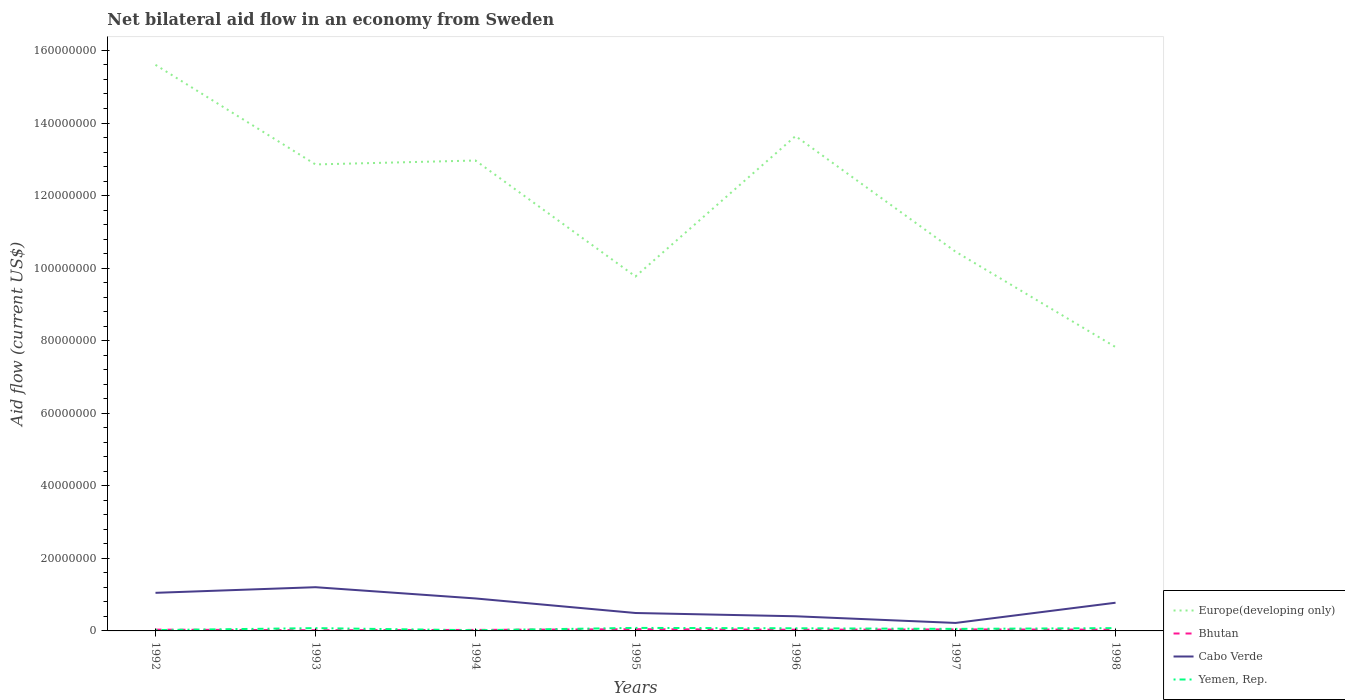Is the number of lines equal to the number of legend labels?
Your response must be concise. Yes. Across all years, what is the maximum net bilateral aid flow in Bhutan?
Your answer should be very brief. 1.90e+05. What is the difference between the highest and the second highest net bilateral aid flow in Cabo Verde?
Provide a short and direct response. 9.85e+06. What is the difference between the highest and the lowest net bilateral aid flow in Yemen, Rep.?
Provide a short and direct response. 4. How many years are there in the graph?
Make the answer very short. 7. Where does the legend appear in the graph?
Your answer should be very brief. Bottom right. How many legend labels are there?
Provide a succinct answer. 4. How are the legend labels stacked?
Offer a terse response. Vertical. What is the title of the graph?
Your response must be concise. Net bilateral aid flow in an economy from Sweden. Does "Uzbekistan" appear as one of the legend labels in the graph?
Make the answer very short. No. What is the label or title of the X-axis?
Your answer should be compact. Years. What is the label or title of the Y-axis?
Offer a very short reply. Aid flow (current US$). What is the Aid flow (current US$) of Europe(developing only) in 1992?
Keep it short and to the point. 1.56e+08. What is the Aid flow (current US$) of Cabo Verde in 1992?
Offer a very short reply. 1.05e+07. What is the Aid flow (current US$) of Europe(developing only) in 1993?
Your answer should be very brief. 1.29e+08. What is the Aid flow (current US$) in Bhutan in 1993?
Offer a terse response. 1.90e+05. What is the Aid flow (current US$) of Cabo Verde in 1993?
Offer a terse response. 1.20e+07. What is the Aid flow (current US$) of Yemen, Rep. in 1993?
Keep it short and to the point. 7.70e+05. What is the Aid flow (current US$) of Europe(developing only) in 1994?
Keep it short and to the point. 1.30e+08. What is the Aid flow (current US$) in Bhutan in 1994?
Ensure brevity in your answer.  2.80e+05. What is the Aid flow (current US$) in Cabo Verde in 1994?
Your response must be concise. 8.95e+06. What is the Aid flow (current US$) of Europe(developing only) in 1995?
Give a very brief answer. 9.77e+07. What is the Aid flow (current US$) in Cabo Verde in 1995?
Provide a short and direct response. 4.94e+06. What is the Aid flow (current US$) of Yemen, Rep. in 1995?
Make the answer very short. 8.30e+05. What is the Aid flow (current US$) of Europe(developing only) in 1996?
Ensure brevity in your answer.  1.36e+08. What is the Aid flow (current US$) in Cabo Verde in 1996?
Ensure brevity in your answer.  4.04e+06. What is the Aid flow (current US$) of Yemen, Rep. in 1996?
Give a very brief answer. 7.30e+05. What is the Aid flow (current US$) of Europe(developing only) in 1997?
Your answer should be compact. 1.05e+08. What is the Aid flow (current US$) in Cabo Verde in 1997?
Give a very brief answer. 2.20e+06. What is the Aid flow (current US$) in Yemen, Rep. in 1997?
Offer a terse response. 5.60e+05. What is the Aid flow (current US$) of Europe(developing only) in 1998?
Your response must be concise. 7.82e+07. What is the Aid flow (current US$) of Bhutan in 1998?
Your response must be concise. 3.50e+05. What is the Aid flow (current US$) of Cabo Verde in 1998?
Your response must be concise. 7.77e+06. What is the Aid flow (current US$) in Yemen, Rep. in 1998?
Offer a very short reply. 7.70e+05. Across all years, what is the maximum Aid flow (current US$) of Europe(developing only)?
Your response must be concise. 1.56e+08. Across all years, what is the maximum Aid flow (current US$) in Cabo Verde?
Your response must be concise. 1.20e+07. Across all years, what is the maximum Aid flow (current US$) of Yemen, Rep.?
Ensure brevity in your answer.  8.30e+05. Across all years, what is the minimum Aid flow (current US$) in Europe(developing only)?
Offer a terse response. 7.82e+07. Across all years, what is the minimum Aid flow (current US$) in Cabo Verde?
Make the answer very short. 2.20e+06. Across all years, what is the minimum Aid flow (current US$) in Yemen, Rep.?
Give a very brief answer. 1.90e+05. What is the total Aid flow (current US$) of Europe(developing only) in the graph?
Offer a very short reply. 8.31e+08. What is the total Aid flow (current US$) of Bhutan in the graph?
Your response must be concise. 2.40e+06. What is the total Aid flow (current US$) of Cabo Verde in the graph?
Give a very brief answer. 5.04e+07. What is the total Aid flow (current US$) of Yemen, Rep. in the graph?
Ensure brevity in your answer.  4.08e+06. What is the difference between the Aid flow (current US$) of Europe(developing only) in 1992 and that in 1993?
Your answer should be very brief. 2.74e+07. What is the difference between the Aid flow (current US$) in Bhutan in 1992 and that in 1993?
Offer a very short reply. 1.60e+05. What is the difference between the Aid flow (current US$) of Cabo Verde in 1992 and that in 1993?
Provide a succinct answer. -1.55e+06. What is the difference between the Aid flow (current US$) of Yemen, Rep. in 1992 and that in 1993?
Make the answer very short. -5.40e+05. What is the difference between the Aid flow (current US$) in Europe(developing only) in 1992 and that in 1994?
Your response must be concise. 2.64e+07. What is the difference between the Aid flow (current US$) in Cabo Verde in 1992 and that in 1994?
Your answer should be very brief. 1.55e+06. What is the difference between the Aid flow (current US$) of Europe(developing only) in 1992 and that in 1995?
Make the answer very short. 5.83e+07. What is the difference between the Aid flow (current US$) of Bhutan in 1992 and that in 1995?
Ensure brevity in your answer.  -1.30e+05. What is the difference between the Aid flow (current US$) of Cabo Verde in 1992 and that in 1995?
Keep it short and to the point. 5.56e+06. What is the difference between the Aid flow (current US$) of Yemen, Rep. in 1992 and that in 1995?
Offer a terse response. -6.00e+05. What is the difference between the Aid flow (current US$) in Europe(developing only) in 1992 and that in 1996?
Give a very brief answer. 1.96e+07. What is the difference between the Aid flow (current US$) of Cabo Verde in 1992 and that in 1996?
Your answer should be compact. 6.46e+06. What is the difference between the Aid flow (current US$) of Yemen, Rep. in 1992 and that in 1996?
Provide a succinct answer. -5.00e+05. What is the difference between the Aid flow (current US$) of Europe(developing only) in 1992 and that in 1997?
Offer a very short reply. 5.15e+07. What is the difference between the Aid flow (current US$) of Bhutan in 1992 and that in 1997?
Provide a succinct answer. -7.00e+04. What is the difference between the Aid flow (current US$) in Cabo Verde in 1992 and that in 1997?
Keep it short and to the point. 8.30e+06. What is the difference between the Aid flow (current US$) of Yemen, Rep. in 1992 and that in 1997?
Offer a terse response. -3.30e+05. What is the difference between the Aid flow (current US$) in Europe(developing only) in 1992 and that in 1998?
Offer a terse response. 7.78e+07. What is the difference between the Aid flow (current US$) in Cabo Verde in 1992 and that in 1998?
Provide a succinct answer. 2.73e+06. What is the difference between the Aid flow (current US$) of Yemen, Rep. in 1992 and that in 1998?
Offer a terse response. -5.40e+05. What is the difference between the Aid flow (current US$) in Europe(developing only) in 1993 and that in 1994?
Your answer should be very brief. -1.08e+06. What is the difference between the Aid flow (current US$) in Cabo Verde in 1993 and that in 1994?
Ensure brevity in your answer.  3.10e+06. What is the difference between the Aid flow (current US$) in Yemen, Rep. in 1993 and that in 1994?
Offer a terse response. 5.80e+05. What is the difference between the Aid flow (current US$) of Europe(developing only) in 1993 and that in 1995?
Provide a succinct answer. 3.09e+07. What is the difference between the Aid flow (current US$) of Cabo Verde in 1993 and that in 1995?
Offer a terse response. 7.11e+06. What is the difference between the Aid flow (current US$) of Europe(developing only) in 1993 and that in 1996?
Your answer should be compact. -7.82e+06. What is the difference between the Aid flow (current US$) of Cabo Verde in 1993 and that in 1996?
Your answer should be very brief. 8.01e+06. What is the difference between the Aid flow (current US$) in Yemen, Rep. in 1993 and that in 1996?
Keep it short and to the point. 4.00e+04. What is the difference between the Aid flow (current US$) of Europe(developing only) in 1993 and that in 1997?
Provide a short and direct response. 2.40e+07. What is the difference between the Aid flow (current US$) in Bhutan in 1993 and that in 1997?
Your response must be concise. -2.30e+05. What is the difference between the Aid flow (current US$) in Cabo Verde in 1993 and that in 1997?
Your answer should be compact. 9.85e+06. What is the difference between the Aid flow (current US$) in Europe(developing only) in 1993 and that in 1998?
Your answer should be very brief. 5.03e+07. What is the difference between the Aid flow (current US$) in Bhutan in 1993 and that in 1998?
Provide a succinct answer. -1.60e+05. What is the difference between the Aid flow (current US$) of Cabo Verde in 1993 and that in 1998?
Keep it short and to the point. 4.28e+06. What is the difference between the Aid flow (current US$) of Yemen, Rep. in 1993 and that in 1998?
Make the answer very short. 0. What is the difference between the Aid flow (current US$) of Europe(developing only) in 1994 and that in 1995?
Make the answer very short. 3.20e+07. What is the difference between the Aid flow (current US$) of Cabo Verde in 1994 and that in 1995?
Your response must be concise. 4.01e+06. What is the difference between the Aid flow (current US$) in Yemen, Rep. in 1994 and that in 1995?
Offer a very short reply. -6.40e+05. What is the difference between the Aid flow (current US$) in Europe(developing only) in 1994 and that in 1996?
Provide a short and direct response. -6.74e+06. What is the difference between the Aid flow (current US$) of Cabo Verde in 1994 and that in 1996?
Your answer should be compact. 4.91e+06. What is the difference between the Aid flow (current US$) in Yemen, Rep. in 1994 and that in 1996?
Give a very brief answer. -5.40e+05. What is the difference between the Aid flow (current US$) of Europe(developing only) in 1994 and that in 1997?
Your answer should be compact. 2.51e+07. What is the difference between the Aid flow (current US$) in Cabo Verde in 1994 and that in 1997?
Provide a short and direct response. 6.75e+06. What is the difference between the Aid flow (current US$) in Yemen, Rep. in 1994 and that in 1997?
Provide a succinct answer. -3.70e+05. What is the difference between the Aid flow (current US$) in Europe(developing only) in 1994 and that in 1998?
Make the answer very short. 5.14e+07. What is the difference between the Aid flow (current US$) of Cabo Verde in 1994 and that in 1998?
Make the answer very short. 1.18e+06. What is the difference between the Aid flow (current US$) of Yemen, Rep. in 1994 and that in 1998?
Give a very brief answer. -5.80e+05. What is the difference between the Aid flow (current US$) of Europe(developing only) in 1995 and that in 1996?
Your answer should be compact. -3.87e+07. What is the difference between the Aid flow (current US$) of Cabo Verde in 1995 and that in 1996?
Your answer should be compact. 9.00e+05. What is the difference between the Aid flow (current US$) in Europe(developing only) in 1995 and that in 1997?
Make the answer very short. -6.84e+06. What is the difference between the Aid flow (current US$) of Cabo Verde in 1995 and that in 1997?
Make the answer very short. 2.74e+06. What is the difference between the Aid flow (current US$) in Yemen, Rep. in 1995 and that in 1997?
Offer a terse response. 2.70e+05. What is the difference between the Aid flow (current US$) of Europe(developing only) in 1995 and that in 1998?
Your response must be concise. 1.95e+07. What is the difference between the Aid flow (current US$) in Bhutan in 1995 and that in 1998?
Offer a terse response. 1.30e+05. What is the difference between the Aid flow (current US$) of Cabo Verde in 1995 and that in 1998?
Offer a very short reply. -2.83e+06. What is the difference between the Aid flow (current US$) in Europe(developing only) in 1996 and that in 1997?
Your answer should be compact. 3.19e+07. What is the difference between the Aid flow (current US$) in Cabo Verde in 1996 and that in 1997?
Make the answer very short. 1.84e+06. What is the difference between the Aid flow (current US$) in Europe(developing only) in 1996 and that in 1998?
Give a very brief answer. 5.82e+07. What is the difference between the Aid flow (current US$) of Cabo Verde in 1996 and that in 1998?
Your answer should be very brief. -3.73e+06. What is the difference between the Aid flow (current US$) of Yemen, Rep. in 1996 and that in 1998?
Make the answer very short. -4.00e+04. What is the difference between the Aid flow (current US$) of Europe(developing only) in 1997 and that in 1998?
Offer a very short reply. 2.63e+07. What is the difference between the Aid flow (current US$) of Cabo Verde in 1997 and that in 1998?
Keep it short and to the point. -5.57e+06. What is the difference between the Aid flow (current US$) of Yemen, Rep. in 1997 and that in 1998?
Offer a terse response. -2.10e+05. What is the difference between the Aid flow (current US$) of Europe(developing only) in 1992 and the Aid flow (current US$) of Bhutan in 1993?
Keep it short and to the point. 1.56e+08. What is the difference between the Aid flow (current US$) in Europe(developing only) in 1992 and the Aid flow (current US$) in Cabo Verde in 1993?
Provide a short and direct response. 1.44e+08. What is the difference between the Aid flow (current US$) of Europe(developing only) in 1992 and the Aid flow (current US$) of Yemen, Rep. in 1993?
Give a very brief answer. 1.55e+08. What is the difference between the Aid flow (current US$) in Bhutan in 1992 and the Aid flow (current US$) in Cabo Verde in 1993?
Provide a short and direct response. -1.17e+07. What is the difference between the Aid flow (current US$) in Bhutan in 1992 and the Aid flow (current US$) in Yemen, Rep. in 1993?
Provide a short and direct response. -4.20e+05. What is the difference between the Aid flow (current US$) of Cabo Verde in 1992 and the Aid flow (current US$) of Yemen, Rep. in 1993?
Make the answer very short. 9.73e+06. What is the difference between the Aid flow (current US$) in Europe(developing only) in 1992 and the Aid flow (current US$) in Bhutan in 1994?
Your answer should be compact. 1.56e+08. What is the difference between the Aid flow (current US$) in Europe(developing only) in 1992 and the Aid flow (current US$) in Cabo Verde in 1994?
Offer a very short reply. 1.47e+08. What is the difference between the Aid flow (current US$) in Europe(developing only) in 1992 and the Aid flow (current US$) in Yemen, Rep. in 1994?
Keep it short and to the point. 1.56e+08. What is the difference between the Aid flow (current US$) in Bhutan in 1992 and the Aid flow (current US$) in Cabo Verde in 1994?
Ensure brevity in your answer.  -8.60e+06. What is the difference between the Aid flow (current US$) in Cabo Verde in 1992 and the Aid flow (current US$) in Yemen, Rep. in 1994?
Offer a very short reply. 1.03e+07. What is the difference between the Aid flow (current US$) in Europe(developing only) in 1992 and the Aid flow (current US$) in Bhutan in 1995?
Give a very brief answer. 1.56e+08. What is the difference between the Aid flow (current US$) in Europe(developing only) in 1992 and the Aid flow (current US$) in Cabo Verde in 1995?
Offer a terse response. 1.51e+08. What is the difference between the Aid flow (current US$) in Europe(developing only) in 1992 and the Aid flow (current US$) in Yemen, Rep. in 1995?
Ensure brevity in your answer.  1.55e+08. What is the difference between the Aid flow (current US$) of Bhutan in 1992 and the Aid flow (current US$) of Cabo Verde in 1995?
Your answer should be compact. -4.59e+06. What is the difference between the Aid flow (current US$) in Bhutan in 1992 and the Aid flow (current US$) in Yemen, Rep. in 1995?
Provide a short and direct response. -4.80e+05. What is the difference between the Aid flow (current US$) of Cabo Verde in 1992 and the Aid flow (current US$) of Yemen, Rep. in 1995?
Keep it short and to the point. 9.67e+06. What is the difference between the Aid flow (current US$) in Europe(developing only) in 1992 and the Aid flow (current US$) in Bhutan in 1996?
Provide a succinct answer. 1.56e+08. What is the difference between the Aid flow (current US$) in Europe(developing only) in 1992 and the Aid flow (current US$) in Cabo Verde in 1996?
Provide a short and direct response. 1.52e+08. What is the difference between the Aid flow (current US$) of Europe(developing only) in 1992 and the Aid flow (current US$) of Yemen, Rep. in 1996?
Your answer should be very brief. 1.55e+08. What is the difference between the Aid flow (current US$) of Bhutan in 1992 and the Aid flow (current US$) of Cabo Verde in 1996?
Your answer should be compact. -3.69e+06. What is the difference between the Aid flow (current US$) in Bhutan in 1992 and the Aid flow (current US$) in Yemen, Rep. in 1996?
Ensure brevity in your answer.  -3.80e+05. What is the difference between the Aid flow (current US$) in Cabo Verde in 1992 and the Aid flow (current US$) in Yemen, Rep. in 1996?
Keep it short and to the point. 9.77e+06. What is the difference between the Aid flow (current US$) in Europe(developing only) in 1992 and the Aid flow (current US$) in Bhutan in 1997?
Ensure brevity in your answer.  1.56e+08. What is the difference between the Aid flow (current US$) of Europe(developing only) in 1992 and the Aid flow (current US$) of Cabo Verde in 1997?
Provide a short and direct response. 1.54e+08. What is the difference between the Aid flow (current US$) in Europe(developing only) in 1992 and the Aid flow (current US$) in Yemen, Rep. in 1997?
Ensure brevity in your answer.  1.55e+08. What is the difference between the Aid flow (current US$) in Bhutan in 1992 and the Aid flow (current US$) in Cabo Verde in 1997?
Offer a terse response. -1.85e+06. What is the difference between the Aid flow (current US$) in Bhutan in 1992 and the Aid flow (current US$) in Yemen, Rep. in 1997?
Keep it short and to the point. -2.10e+05. What is the difference between the Aid flow (current US$) in Cabo Verde in 1992 and the Aid flow (current US$) in Yemen, Rep. in 1997?
Offer a terse response. 9.94e+06. What is the difference between the Aid flow (current US$) of Europe(developing only) in 1992 and the Aid flow (current US$) of Bhutan in 1998?
Provide a short and direct response. 1.56e+08. What is the difference between the Aid flow (current US$) of Europe(developing only) in 1992 and the Aid flow (current US$) of Cabo Verde in 1998?
Your response must be concise. 1.48e+08. What is the difference between the Aid flow (current US$) of Europe(developing only) in 1992 and the Aid flow (current US$) of Yemen, Rep. in 1998?
Offer a very short reply. 1.55e+08. What is the difference between the Aid flow (current US$) of Bhutan in 1992 and the Aid flow (current US$) of Cabo Verde in 1998?
Offer a very short reply. -7.42e+06. What is the difference between the Aid flow (current US$) of Bhutan in 1992 and the Aid flow (current US$) of Yemen, Rep. in 1998?
Make the answer very short. -4.20e+05. What is the difference between the Aid flow (current US$) of Cabo Verde in 1992 and the Aid flow (current US$) of Yemen, Rep. in 1998?
Make the answer very short. 9.73e+06. What is the difference between the Aid flow (current US$) in Europe(developing only) in 1993 and the Aid flow (current US$) in Bhutan in 1994?
Keep it short and to the point. 1.28e+08. What is the difference between the Aid flow (current US$) of Europe(developing only) in 1993 and the Aid flow (current US$) of Cabo Verde in 1994?
Provide a succinct answer. 1.20e+08. What is the difference between the Aid flow (current US$) in Europe(developing only) in 1993 and the Aid flow (current US$) in Yemen, Rep. in 1994?
Give a very brief answer. 1.28e+08. What is the difference between the Aid flow (current US$) of Bhutan in 1993 and the Aid flow (current US$) of Cabo Verde in 1994?
Make the answer very short. -8.76e+06. What is the difference between the Aid flow (current US$) in Cabo Verde in 1993 and the Aid flow (current US$) in Yemen, Rep. in 1994?
Your answer should be compact. 1.19e+07. What is the difference between the Aid flow (current US$) in Europe(developing only) in 1993 and the Aid flow (current US$) in Bhutan in 1995?
Make the answer very short. 1.28e+08. What is the difference between the Aid flow (current US$) of Europe(developing only) in 1993 and the Aid flow (current US$) of Cabo Verde in 1995?
Your response must be concise. 1.24e+08. What is the difference between the Aid flow (current US$) of Europe(developing only) in 1993 and the Aid flow (current US$) of Yemen, Rep. in 1995?
Keep it short and to the point. 1.28e+08. What is the difference between the Aid flow (current US$) of Bhutan in 1993 and the Aid flow (current US$) of Cabo Verde in 1995?
Provide a succinct answer. -4.75e+06. What is the difference between the Aid flow (current US$) of Bhutan in 1993 and the Aid flow (current US$) of Yemen, Rep. in 1995?
Make the answer very short. -6.40e+05. What is the difference between the Aid flow (current US$) in Cabo Verde in 1993 and the Aid flow (current US$) in Yemen, Rep. in 1995?
Offer a terse response. 1.12e+07. What is the difference between the Aid flow (current US$) in Europe(developing only) in 1993 and the Aid flow (current US$) in Bhutan in 1996?
Keep it short and to the point. 1.28e+08. What is the difference between the Aid flow (current US$) of Europe(developing only) in 1993 and the Aid flow (current US$) of Cabo Verde in 1996?
Provide a succinct answer. 1.25e+08. What is the difference between the Aid flow (current US$) in Europe(developing only) in 1993 and the Aid flow (current US$) in Yemen, Rep. in 1996?
Offer a very short reply. 1.28e+08. What is the difference between the Aid flow (current US$) of Bhutan in 1993 and the Aid flow (current US$) of Cabo Verde in 1996?
Give a very brief answer. -3.85e+06. What is the difference between the Aid flow (current US$) in Bhutan in 1993 and the Aid flow (current US$) in Yemen, Rep. in 1996?
Provide a succinct answer. -5.40e+05. What is the difference between the Aid flow (current US$) in Cabo Verde in 1993 and the Aid flow (current US$) in Yemen, Rep. in 1996?
Make the answer very short. 1.13e+07. What is the difference between the Aid flow (current US$) of Europe(developing only) in 1993 and the Aid flow (current US$) of Bhutan in 1997?
Your answer should be compact. 1.28e+08. What is the difference between the Aid flow (current US$) in Europe(developing only) in 1993 and the Aid flow (current US$) in Cabo Verde in 1997?
Your response must be concise. 1.26e+08. What is the difference between the Aid flow (current US$) in Europe(developing only) in 1993 and the Aid flow (current US$) in Yemen, Rep. in 1997?
Your response must be concise. 1.28e+08. What is the difference between the Aid flow (current US$) in Bhutan in 1993 and the Aid flow (current US$) in Cabo Verde in 1997?
Offer a terse response. -2.01e+06. What is the difference between the Aid flow (current US$) in Bhutan in 1993 and the Aid flow (current US$) in Yemen, Rep. in 1997?
Keep it short and to the point. -3.70e+05. What is the difference between the Aid flow (current US$) of Cabo Verde in 1993 and the Aid flow (current US$) of Yemen, Rep. in 1997?
Keep it short and to the point. 1.15e+07. What is the difference between the Aid flow (current US$) in Europe(developing only) in 1993 and the Aid flow (current US$) in Bhutan in 1998?
Make the answer very short. 1.28e+08. What is the difference between the Aid flow (current US$) of Europe(developing only) in 1993 and the Aid flow (current US$) of Cabo Verde in 1998?
Keep it short and to the point. 1.21e+08. What is the difference between the Aid flow (current US$) of Europe(developing only) in 1993 and the Aid flow (current US$) of Yemen, Rep. in 1998?
Your response must be concise. 1.28e+08. What is the difference between the Aid flow (current US$) in Bhutan in 1993 and the Aid flow (current US$) in Cabo Verde in 1998?
Give a very brief answer. -7.58e+06. What is the difference between the Aid flow (current US$) of Bhutan in 1993 and the Aid flow (current US$) of Yemen, Rep. in 1998?
Your answer should be compact. -5.80e+05. What is the difference between the Aid flow (current US$) of Cabo Verde in 1993 and the Aid flow (current US$) of Yemen, Rep. in 1998?
Provide a succinct answer. 1.13e+07. What is the difference between the Aid flow (current US$) in Europe(developing only) in 1994 and the Aid flow (current US$) in Bhutan in 1995?
Your response must be concise. 1.29e+08. What is the difference between the Aid flow (current US$) of Europe(developing only) in 1994 and the Aid flow (current US$) of Cabo Verde in 1995?
Keep it short and to the point. 1.25e+08. What is the difference between the Aid flow (current US$) of Europe(developing only) in 1994 and the Aid flow (current US$) of Yemen, Rep. in 1995?
Provide a succinct answer. 1.29e+08. What is the difference between the Aid flow (current US$) of Bhutan in 1994 and the Aid flow (current US$) of Cabo Verde in 1995?
Offer a terse response. -4.66e+06. What is the difference between the Aid flow (current US$) of Bhutan in 1994 and the Aid flow (current US$) of Yemen, Rep. in 1995?
Keep it short and to the point. -5.50e+05. What is the difference between the Aid flow (current US$) of Cabo Verde in 1994 and the Aid flow (current US$) of Yemen, Rep. in 1995?
Your answer should be very brief. 8.12e+06. What is the difference between the Aid flow (current US$) of Europe(developing only) in 1994 and the Aid flow (current US$) of Bhutan in 1996?
Make the answer very short. 1.29e+08. What is the difference between the Aid flow (current US$) in Europe(developing only) in 1994 and the Aid flow (current US$) in Cabo Verde in 1996?
Your answer should be very brief. 1.26e+08. What is the difference between the Aid flow (current US$) in Europe(developing only) in 1994 and the Aid flow (current US$) in Yemen, Rep. in 1996?
Offer a very short reply. 1.29e+08. What is the difference between the Aid flow (current US$) of Bhutan in 1994 and the Aid flow (current US$) of Cabo Verde in 1996?
Ensure brevity in your answer.  -3.76e+06. What is the difference between the Aid flow (current US$) in Bhutan in 1994 and the Aid flow (current US$) in Yemen, Rep. in 1996?
Provide a short and direct response. -4.50e+05. What is the difference between the Aid flow (current US$) in Cabo Verde in 1994 and the Aid flow (current US$) in Yemen, Rep. in 1996?
Your response must be concise. 8.22e+06. What is the difference between the Aid flow (current US$) in Europe(developing only) in 1994 and the Aid flow (current US$) in Bhutan in 1997?
Ensure brevity in your answer.  1.29e+08. What is the difference between the Aid flow (current US$) of Europe(developing only) in 1994 and the Aid flow (current US$) of Cabo Verde in 1997?
Keep it short and to the point. 1.27e+08. What is the difference between the Aid flow (current US$) of Europe(developing only) in 1994 and the Aid flow (current US$) of Yemen, Rep. in 1997?
Keep it short and to the point. 1.29e+08. What is the difference between the Aid flow (current US$) in Bhutan in 1994 and the Aid flow (current US$) in Cabo Verde in 1997?
Make the answer very short. -1.92e+06. What is the difference between the Aid flow (current US$) in Bhutan in 1994 and the Aid flow (current US$) in Yemen, Rep. in 1997?
Your answer should be very brief. -2.80e+05. What is the difference between the Aid flow (current US$) in Cabo Verde in 1994 and the Aid flow (current US$) in Yemen, Rep. in 1997?
Your answer should be very brief. 8.39e+06. What is the difference between the Aid flow (current US$) in Europe(developing only) in 1994 and the Aid flow (current US$) in Bhutan in 1998?
Make the answer very short. 1.29e+08. What is the difference between the Aid flow (current US$) of Europe(developing only) in 1994 and the Aid flow (current US$) of Cabo Verde in 1998?
Offer a very short reply. 1.22e+08. What is the difference between the Aid flow (current US$) in Europe(developing only) in 1994 and the Aid flow (current US$) in Yemen, Rep. in 1998?
Provide a short and direct response. 1.29e+08. What is the difference between the Aid flow (current US$) of Bhutan in 1994 and the Aid flow (current US$) of Cabo Verde in 1998?
Ensure brevity in your answer.  -7.49e+06. What is the difference between the Aid flow (current US$) in Bhutan in 1994 and the Aid flow (current US$) in Yemen, Rep. in 1998?
Ensure brevity in your answer.  -4.90e+05. What is the difference between the Aid flow (current US$) of Cabo Verde in 1994 and the Aid flow (current US$) of Yemen, Rep. in 1998?
Make the answer very short. 8.18e+06. What is the difference between the Aid flow (current US$) in Europe(developing only) in 1995 and the Aid flow (current US$) in Bhutan in 1996?
Ensure brevity in your answer.  9.74e+07. What is the difference between the Aid flow (current US$) in Europe(developing only) in 1995 and the Aid flow (current US$) in Cabo Verde in 1996?
Give a very brief answer. 9.37e+07. What is the difference between the Aid flow (current US$) of Europe(developing only) in 1995 and the Aid flow (current US$) of Yemen, Rep. in 1996?
Ensure brevity in your answer.  9.70e+07. What is the difference between the Aid flow (current US$) in Bhutan in 1995 and the Aid flow (current US$) in Cabo Verde in 1996?
Provide a succinct answer. -3.56e+06. What is the difference between the Aid flow (current US$) in Bhutan in 1995 and the Aid flow (current US$) in Yemen, Rep. in 1996?
Offer a terse response. -2.50e+05. What is the difference between the Aid flow (current US$) of Cabo Verde in 1995 and the Aid flow (current US$) of Yemen, Rep. in 1996?
Offer a very short reply. 4.21e+06. What is the difference between the Aid flow (current US$) in Europe(developing only) in 1995 and the Aid flow (current US$) in Bhutan in 1997?
Provide a succinct answer. 9.73e+07. What is the difference between the Aid flow (current US$) of Europe(developing only) in 1995 and the Aid flow (current US$) of Cabo Verde in 1997?
Ensure brevity in your answer.  9.55e+07. What is the difference between the Aid flow (current US$) in Europe(developing only) in 1995 and the Aid flow (current US$) in Yemen, Rep. in 1997?
Offer a very short reply. 9.71e+07. What is the difference between the Aid flow (current US$) of Bhutan in 1995 and the Aid flow (current US$) of Cabo Verde in 1997?
Offer a very short reply. -1.72e+06. What is the difference between the Aid flow (current US$) of Bhutan in 1995 and the Aid flow (current US$) of Yemen, Rep. in 1997?
Offer a very short reply. -8.00e+04. What is the difference between the Aid flow (current US$) of Cabo Verde in 1995 and the Aid flow (current US$) of Yemen, Rep. in 1997?
Your answer should be very brief. 4.38e+06. What is the difference between the Aid flow (current US$) of Europe(developing only) in 1995 and the Aid flow (current US$) of Bhutan in 1998?
Provide a short and direct response. 9.74e+07. What is the difference between the Aid flow (current US$) of Europe(developing only) in 1995 and the Aid flow (current US$) of Cabo Verde in 1998?
Your response must be concise. 8.99e+07. What is the difference between the Aid flow (current US$) of Europe(developing only) in 1995 and the Aid flow (current US$) of Yemen, Rep. in 1998?
Ensure brevity in your answer.  9.69e+07. What is the difference between the Aid flow (current US$) in Bhutan in 1995 and the Aid flow (current US$) in Cabo Verde in 1998?
Offer a very short reply. -7.29e+06. What is the difference between the Aid flow (current US$) in Cabo Verde in 1995 and the Aid flow (current US$) in Yemen, Rep. in 1998?
Offer a terse response. 4.17e+06. What is the difference between the Aid flow (current US$) of Europe(developing only) in 1996 and the Aid flow (current US$) of Bhutan in 1997?
Your answer should be compact. 1.36e+08. What is the difference between the Aid flow (current US$) in Europe(developing only) in 1996 and the Aid flow (current US$) in Cabo Verde in 1997?
Offer a very short reply. 1.34e+08. What is the difference between the Aid flow (current US$) of Europe(developing only) in 1996 and the Aid flow (current US$) of Yemen, Rep. in 1997?
Offer a very short reply. 1.36e+08. What is the difference between the Aid flow (current US$) of Bhutan in 1996 and the Aid flow (current US$) of Cabo Verde in 1997?
Keep it short and to the point. -1.87e+06. What is the difference between the Aid flow (current US$) in Bhutan in 1996 and the Aid flow (current US$) in Yemen, Rep. in 1997?
Your answer should be very brief. -2.30e+05. What is the difference between the Aid flow (current US$) of Cabo Verde in 1996 and the Aid flow (current US$) of Yemen, Rep. in 1997?
Your response must be concise. 3.48e+06. What is the difference between the Aid flow (current US$) in Europe(developing only) in 1996 and the Aid flow (current US$) in Bhutan in 1998?
Offer a terse response. 1.36e+08. What is the difference between the Aid flow (current US$) of Europe(developing only) in 1996 and the Aid flow (current US$) of Cabo Verde in 1998?
Give a very brief answer. 1.29e+08. What is the difference between the Aid flow (current US$) of Europe(developing only) in 1996 and the Aid flow (current US$) of Yemen, Rep. in 1998?
Offer a terse response. 1.36e+08. What is the difference between the Aid flow (current US$) in Bhutan in 1996 and the Aid flow (current US$) in Cabo Verde in 1998?
Your answer should be compact. -7.44e+06. What is the difference between the Aid flow (current US$) of Bhutan in 1996 and the Aid flow (current US$) of Yemen, Rep. in 1998?
Provide a short and direct response. -4.40e+05. What is the difference between the Aid flow (current US$) of Cabo Verde in 1996 and the Aid flow (current US$) of Yemen, Rep. in 1998?
Your answer should be compact. 3.27e+06. What is the difference between the Aid flow (current US$) in Europe(developing only) in 1997 and the Aid flow (current US$) in Bhutan in 1998?
Offer a very short reply. 1.04e+08. What is the difference between the Aid flow (current US$) of Europe(developing only) in 1997 and the Aid flow (current US$) of Cabo Verde in 1998?
Your answer should be compact. 9.68e+07. What is the difference between the Aid flow (current US$) in Europe(developing only) in 1997 and the Aid flow (current US$) in Yemen, Rep. in 1998?
Keep it short and to the point. 1.04e+08. What is the difference between the Aid flow (current US$) in Bhutan in 1997 and the Aid flow (current US$) in Cabo Verde in 1998?
Your answer should be compact. -7.35e+06. What is the difference between the Aid flow (current US$) of Bhutan in 1997 and the Aid flow (current US$) of Yemen, Rep. in 1998?
Offer a terse response. -3.50e+05. What is the difference between the Aid flow (current US$) in Cabo Verde in 1997 and the Aid flow (current US$) in Yemen, Rep. in 1998?
Provide a succinct answer. 1.43e+06. What is the average Aid flow (current US$) of Europe(developing only) per year?
Ensure brevity in your answer.  1.19e+08. What is the average Aid flow (current US$) of Bhutan per year?
Offer a very short reply. 3.43e+05. What is the average Aid flow (current US$) of Cabo Verde per year?
Your response must be concise. 7.21e+06. What is the average Aid flow (current US$) of Yemen, Rep. per year?
Your response must be concise. 5.83e+05. In the year 1992, what is the difference between the Aid flow (current US$) of Europe(developing only) and Aid flow (current US$) of Bhutan?
Give a very brief answer. 1.56e+08. In the year 1992, what is the difference between the Aid flow (current US$) of Europe(developing only) and Aid flow (current US$) of Cabo Verde?
Your answer should be very brief. 1.46e+08. In the year 1992, what is the difference between the Aid flow (current US$) of Europe(developing only) and Aid flow (current US$) of Yemen, Rep.?
Provide a short and direct response. 1.56e+08. In the year 1992, what is the difference between the Aid flow (current US$) in Bhutan and Aid flow (current US$) in Cabo Verde?
Provide a succinct answer. -1.02e+07. In the year 1992, what is the difference between the Aid flow (current US$) in Bhutan and Aid flow (current US$) in Yemen, Rep.?
Make the answer very short. 1.20e+05. In the year 1992, what is the difference between the Aid flow (current US$) in Cabo Verde and Aid flow (current US$) in Yemen, Rep.?
Your answer should be compact. 1.03e+07. In the year 1993, what is the difference between the Aid flow (current US$) in Europe(developing only) and Aid flow (current US$) in Bhutan?
Ensure brevity in your answer.  1.28e+08. In the year 1993, what is the difference between the Aid flow (current US$) of Europe(developing only) and Aid flow (current US$) of Cabo Verde?
Your response must be concise. 1.17e+08. In the year 1993, what is the difference between the Aid flow (current US$) in Europe(developing only) and Aid flow (current US$) in Yemen, Rep.?
Ensure brevity in your answer.  1.28e+08. In the year 1993, what is the difference between the Aid flow (current US$) in Bhutan and Aid flow (current US$) in Cabo Verde?
Offer a terse response. -1.19e+07. In the year 1993, what is the difference between the Aid flow (current US$) in Bhutan and Aid flow (current US$) in Yemen, Rep.?
Make the answer very short. -5.80e+05. In the year 1993, what is the difference between the Aid flow (current US$) of Cabo Verde and Aid flow (current US$) of Yemen, Rep.?
Offer a terse response. 1.13e+07. In the year 1994, what is the difference between the Aid flow (current US$) in Europe(developing only) and Aid flow (current US$) in Bhutan?
Keep it short and to the point. 1.29e+08. In the year 1994, what is the difference between the Aid flow (current US$) of Europe(developing only) and Aid flow (current US$) of Cabo Verde?
Your answer should be very brief. 1.21e+08. In the year 1994, what is the difference between the Aid flow (current US$) of Europe(developing only) and Aid flow (current US$) of Yemen, Rep.?
Ensure brevity in your answer.  1.29e+08. In the year 1994, what is the difference between the Aid flow (current US$) of Bhutan and Aid flow (current US$) of Cabo Verde?
Offer a very short reply. -8.67e+06. In the year 1994, what is the difference between the Aid flow (current US$) of Cabo Verde and Aid flow (current US$) of Yemen, Rep.?
Provide a succinct answer. 8.76e+06. In the year 1995, what is the difference between the Aid flow (current US$) in Europe(developing only) and Aid flow (current US$) in Bhutan?
Your response must be concise. 9.72e+07. In the year 1995, what is the difference between the Aid flow (current US$) of Europe(developing only) and Aid flow (current US$) of Cabo Verde?
Keep it short and to the point. 9.28e+07. In the year 1995, what is the difference between the Aid flow (current US$) in Europe(developing only) and Aid flow (current US$) in Yemen, Rep.?
Ensure brevity in your answer.  9.69e+07. In the year 1995, what is the difference between the Aid flow (current US$) in Bhutan and Aid flow (current US$) in Cabo Verde?
Make the answer very short. -4.46e+06. In the year 1995, what is the difference between the Aid flow (current US$) in Bhutan and Aid flow (current US$) in Yemen, Rep.?
Offer a very short reply. -3.50e+05. In the year 1995, what is the difference between the Aid flow (current US$) in Cabo Verde and Aid flow (current US$) in Yemen, Rep.?
Offer a terse response. 4.11e+06. In the year 1996, what is the difference between the Aid flow (current US$) of Europe(developing only) and Aid flow (current US$) of Bhutan?
Make the answer very short. 1.36e+08. In the year 1996, what is the difference between the Aid flow (current US$) in Europe(developing only) and Aid flow (current US$) in Cabo Verde?
Ensure brevity in your answer.  1.32e+08. In the year 1996, what is the difference between the Aid flow (current US$) of Europe(developing only) and Aid flow (current US$) of Yemen, Rep.?
Your response must be concise. 1.36e+08. In the year 1996, what is the difference between the Aid flow (current US$) in Bhutan and Aid flow (current US$) in Cabo Verde?
Provide a short and direct response. -3.71e+06. In the year 1996, what is the difference between the Aid flow (current US$) of Bhutan and Aid flow (current US$) of Yemen, Rep.?
Offer a very short reply. -4.00e+05. In the year 1996, what is the difference between the Aid flow (current US$) of Cabo Verde and Aid flow (current US$) of Yemen, Rep.?
Ensure brevity in your answer.  3.31e+06. In the year 1997, what is the difference between the Aid flow (current US$) in Europe(developing only) and Aid flow (current US$) in Bhutan?
Offer a very short reply. 1.04e+08. In the year 1997, what is the difference between the Aid flow (current US$) in Europe(developing only) and Aid flow (current US$) in Cabo Verde?
Offer a terse response. 1.02e+08. In the year 1997, what is the difference between the Aid flow (current US$) in Europe(developing only) and Aid flow (current US$) in Yemen, Rep.?
Offer a terse response. 1.04e+08. In the year 1997, what is the difference between the Aid flow (current US$) in Bhutan and Aid flow (current US$) in Cabo Verde?
Ensure brevity in your answer.  -1.78e+06. In the year 1997, what is the difference between the Aid flow (current US$) in Cabo Verde and Aid flow (current US$) in Yemen, Rep.?
Offer a terse response. 1.64e+06. In the year 1998, what is the difference between the Aid flow (current US$) in Europe(developing only) and Aid flow (current US$) in Bhutan?
Offer a very short reply. 7.79e+07. In the year 1998, what is the difference between the Aid flow (current US$) in Europe(developing only) and Aid flow (current US$) in Cabo Verde?
Provide a short and direct response. 7.05e+07. In the year 1998, what is the difference between the Aid flow (current US$) in Europe(developing only) and Aid flow (current US$) in Yemen, Rep.?
Your answer should be compact. 7.75e+07. In the year 1998, what is the difference between the Aid flow (current US$) in Bhutan and Aid flow (current US$) in Cabo Verde?
Give a very brief answer. -7.42e+06. In the year 1998, what is the difference between the Aid flow (current US$) in Bhutan and Aid flow (current US$) in Yemen, Rep.?
Offer a terse response. -4.20e+05. In the year 1998, what is the difference between the Aid flow (current US$) of Cabo Verde and Aid flow (current US$) of Yemen, Rep.?
Your response must be concise. 7.00e+06. What is the ratio of the Aid flow (current US$) in Europe(developing only) in 1992 to that in 1993?
Provide a short and direct response. 1.21. What is the ratio of the Aid flow (current US$) in Bhutan in 1992 to that in 1993?
Provide a short and direct response. 1.84. What is the ratio of the Aid flow (current US$) in Cabo Verde in 1992 to that in 1993?
Ensure brevity in your answer.  0.87. What is the ratio of the Aid flow (current US$) in Yemen, Rep. in 1992 to that in 1993?
Keep it short and to the point. 0.3. What is the ratio of the Aid flow (current US$) in Europe(developing only) in 1992 to that in 1994?
Ensure brevity in your answer.  1.2. What is the ratio of the Aid flow (current US$) in Cabo Verde in 1992 to that in 1994?
Give a very brief answer. 1.17. What is the ratio of the Aid flow (current US$) in Yemen, Rep. in 1992 to that in 1994?
Offer a very short reply. 1.21. What is the ratio of the Aid flow (current US$) in Europe(developing only) in 1992 to that in 1995?
Make the answer very short. 1.6. What is the ratio of the Aid flow (current US$) in Bhutan in 1992 to that in 1995?
Your answer should be very brief. 0.73. What is the ratio of the Aid flow (current US$) of Cabo Verde in 1992 to that in 1995?
Your response must be concise. 2.13. What is the ratio of the Aid flow (current US$) in Yemen, Rep. in 1992 to that in 1995?
Your answer should be compact. 0.28. What is the ratio of the Aid flow (current US$) of Europe(developing only) in 1992 to that in 1996?
Your response must be concise. 1.14. What is the ratio of the Aid flow (current US$) in Bhutan in 1992 to that in 1996?
Offer a terse response. 1.06. What is the ratio of the Aid flow (current US$) of Cabo Verde in 1992 to that in 1996?
Keep it short and to the point. 2.6. What is the ratio of the Aid flow (current US$) of Yemen, Rep. in 1992 to that in 1996?
Your response must be concise. 0.32. What is the ratio of the Aid flow (current US$) in Europe(developing only) in 1992 to that in 1997?
Provide a succinct answer. 1.49. What is the ratio of the Aid flow (current US$) of Bhutan in 1992 to that in 1997?
Keep it short and to the point. 0.83. What is the ratio of the Aid flow (current US$) of Cabo Verde in 1992 to that in 1997?
Your response must be concise. 4.77. What is the ratio of the Aid flow (current US$) in Yemen, Rep. in 1992 to that in 1997?
Keep it short and to the point. 0.41. What is the ratio of the Aid flow (current US$) in Europe(developing only) in 1992 to that in 1998?
Give a very brief answer. 1.99. What is the ratio of the Aid flow (current US$) of Bhutan in 1992 to that in 1998?
Give a very brief answer. 1. What is the ratio of the Aid flow (current US$) of Cabo Verde in 1992 to that in 1998?
Make the answer very short. 1.35. What is the ratio of the Aid flow (current US$) of Yemen, Rep. in 1992 to that in 1998?
Provide a short and direct response. 0.3. What is the ratio of the Aid flow (current US$) in Bhutan in 1993 to that in 1994?
Ensure brevity in your answer.  0.68. What is the ratio of the Aid flow (current US$) in Cabo Verde in 1993 to that in 1994?
Provide a short and direct response. 1.35. What is the ratio of the Aid flow (current US$) of Yemen, Rep. in 1993 to that in 1994?
Ensure brevity in your answer.  4.05. What is the ratio of the Aid flow (current US$) in Europe(developing only) in 1993 to that in 1995?
Make the answer very short. 1.32. What is the ratio of the Aid flow (current US$) in Bhutan in 1993 to that in 1995?
Your response must be concise. 0.4. What is the ratio of the Aid flow (current US$) in Cabo Verde in 1993 to that in 1995?
Provide a short and direct response. 2.44. What is the ratio of the Aid flow (current US$) in Yemen, Rep. in 1993 to that in 1995?
Your answer should be compact. 0.93. What is the ratio of the Aid flow (current US$) in Europe(developing only) in 1993 to that in 1996?
Provide a short and direct response. 0.94. What is the ratio of the Aid flow (current US$) of Bhutan in 1993 to that in 1996?
Make the answer very short. 0.58. What is the ratio of the Aid flow (current US$) of Cabo Verde in 1993 to that in 1996?
Provide a short and direct response. 2.98. What is the ratio of the Aid flow (current US$) of Yemen, Rep. in 1993 to that in 1996?
Keep it short and to the point. 1.05. What is the ratio of the Aid flow (current US$) in Europe(developing only) in 1993 to that in 1997?
Provide a short and direct response. 1.23. What is the ratio of the Aid flow (current US$) in Bhutan in 1993 to that in 1997?
Give a very brief answer. 0.45. What is the ratio of the Aid flow (current US$) of Cabo Verde in 1993 to that in 1997?
Your answer should be compact. 5.48. What is the ratio of the Aid flow (current US$) of Yemen, Rep. in 1993 to that in 1997?
Ensure brevity in your answer.  1.38. What is the ratio of the Aid flow (current US$) of Europe(developing only) in 1993 to that in 1998?
Give a very brief answer. 1.64. What is the ratio of the Aid flow (current US$) in Bhutan in 1993 to that in 1998?
Your answer should be very brief. 0.54. What is the ratio of the Aid flow (current US$) in Cabo Verde in 1993 to that in 1998?
Offer a terse response. 1.55. What is the ratio of the Aid flow (current US$) of Europe(developing only) in 1994 to that in 1995?
Your answer should be compact. 1.33. What is the ratio of the Aid flow (current US$) in Bhutan in 1994 to that in 1995?
Give a very brief answer. 0.58. What is the ratio of the Aid flow (current US$) in Cabo Verde in 1994 to that in 1995?
Your answer should be compact. 1.81. What is the ratio of the Aid flow (current US$) in Yemen, Rep. in 1994 to that in 1995?
Provide a succinct answer. 0.23. What is the ratio of the Aid flow (current US$) in Europe(developing only) in 1994 to that in 1996?
Ensure brevity in your answer.  0.95. What is the ratio of the Aid flow (current US$) in Bhutan in 1994 to that in 1996?
Offer a very short reply. 0.85. What is the ratio of the Aid flow (current US$) in Cabo Verde in 1994 to that in 1996?
Keep it short and to the point. 2.22. What is the ratio of the Aid flow (current US$) of Yemen, Rep. in 1994 to that in 1996?
Provide a succinct answer. 0.26. What is the ratio of the Aid flow (current US$) in Europe(developing only) in 1994 to that in 1997?
Offer a very short reply. 1.24. What is the ratio of the Aid flow (current US$) of Cabo Verde in 1994 to that in 1997?
Give a very brief answer. 4.07. What is the ratio of the Aid flow (current US$) of Yemen, Rep. in 1994 to that in 1997?
Offer a terse response. 0.34. What is the ratio of the Aid flow (current US$) of Europe(developing only) in 1994 to that in 1998?
Your response must be concise. 1.66. What is the ratio of the Aid flow (current US$) in Bhutan in 1994 to that in 1998?
Keep it short and to the point. 0.8. What is the ratio of the Aid flow (current US$) in Cabo Verde in 1994 to that in 1998?
Ensure brevity in your answer.  1.15. What is the ratio of the Aid flow (current US$) in Yemen, Rep. in 1994 to that in 1998?
Your answer should be compact. 0.25. What is the ratio of the Aid flow (current US$) in Europe(developing only) in 1995 to that in 1996?
Provide a short and direct response. 0.72. What is the ratio of the Aid flow (current US$) in Bhutan in 1995 to that in 1996?
Make the answer very short. 1.45. What is the ratio of the Aid flow (current US$) of Cabo Verde in 1995 to that in 1996?
Your answer should be compact. 1.22. What is the ratio of the Aid flow (current US$) of Yemen, Rep. in 1995 to that in 1996?
Your answer should be very brief. 1.14. What is the ratio of the Aid flow (current US$) in Europe(developing only) in 1995 to that in 1997?
Make the answer very short. 0.93. What is the ratio of the Aid flow (current US$) in Bhutan in 1995 to that in 1997?
Provide a short and direct response. 1.14. What is the ratio of the Aid flow (current US$) in Cabo Verde in 1995 to that in 1997?
Make the answer very short. 2.25. What is the ratio of the Aid flow (current US$) of Yemen, Rep. in 1995 to that in 1997?
Offer a very short reply. 1.48. What is the ratio of the Aid flow (current US$) in Europe(developing only) in 1995 to that in 1998?
Offer a very short reply. 1.25. What is the ratio of the Aid flow (current US$) in Bhutan in 1995 to that in 1998?
Provide a succinct answer. 1.37. What is the ratio of the Aid flow (current US$) in Cabo Verde in 1995 to that in 1998?
Offer a very short reply. 0.64. What is the ratio of the Aid flow (current US$) of Yemen, Rep. in 1995 to that in 1998?
Your answer should be compact. 1.08. What is the ratio of the Aid flow (current US$) of Europe(developing only) in 1996 to that in 1997?
Provide a short and direct response. 1.3. What is the ratio of the Aid flow (current US$) of Bhutan in 1996 to that in 1997?
Your answer should be compact. 0.79. What is the ratio of the Aid flow (current US$) of Cabo Verde in 1996 to that in 1997?
Your response must be concise. 1.84. What is the ratio of the Aid flow (current US$) of Yemen, Rep. in 1996 to that in 1997?
Your answer should be very brief. 1.3. What is the ratio of the Aid flow (current US$) of Europe(developing only) in 1996 to that in 1998?
Your response must be concise. 1.74. What is the ratio of the Aid flow (current US$) in Bhutan in 1996 to that in 1998?
Your response must be concise. 0.94. What is the ratio of the Aid flow (current US$) in Cabo Verde in 1996 to that in 1998?
Provide a short and direct response. 0.52. What is the ratio of the Aid flow (current US$) of Yemen, Rep. in 1996 to that in 1998?
Provide a succinct answer. 0.95. What is the ratio of the Aid flow (current US$) of Europe(developing only) in 1997 to that in 1998?
Keep it short and to the point. 1.34. What is the ratio of the Aid flow (current US$) in Cabo Verde in 1997 to that in 1998?
Ensure brevity in your answer.  0.28. What is the ratio of the Aid flow (current US$) of Yemen, Rep. in 1997 to that in 1998?
Your answer should be compact. 0.73. What is the difference between the highest and the second highest Aid flow (current US$) in Europe(developing only)?
Ensure brevity in your answer.  1.96e+07. What is the difference between the highest and the second highest Aid flow (current US$) of Cabo Verde?
Offer a terse response. 1.55e+06. What is the difference between the highest and the lowest Aid flow (current US$) in Europe(developing only)?
Your response must be concise. 7.78e+07. What is the difference between the highest and the lowest Aid flow (current US$) of Bhutan?
Ensure brevity in your answer.  2.90e+05. What is the difference between the highest and the lowest Aid flow (current US$) in Cabo Verde?
Offer a very short reply. 9.85e+06. What is the difference between the highest and the lowest Aid flow (current US$) of Yemen, Rep.?
Provide a short and direct response. 6.40e+05. 